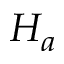<formula> <loc_0><loc_0><loc_500><loc_500>H _ { a }</formula> 